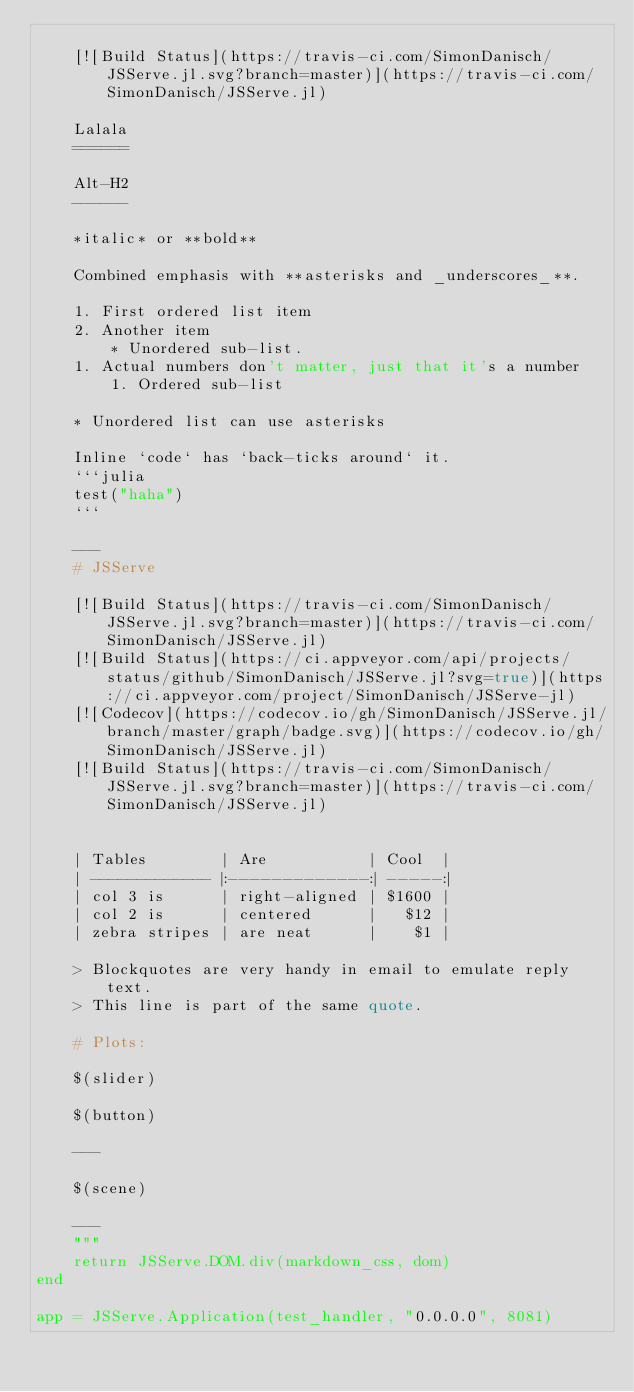<code> <loc_0><loc_0><loc_500><loc_500><_Julia_>
    [![Build Status](https://travis-ci.com/SimonDanisch/JSServe.jl.svg?branch=master)](https://travis-ci.com/SimonDanisch/JSServe.jl)

    Lalala
    ======

    Alt-H2
    ------

    *italic* or **bold**

    Combined emphasis with **asterisks and _underscores_**.

    1. First ordered list item
    2. Another item
        * Unordered sub-list.
    1. Actual numbers don't matter, just that it's a number
        1. Ordered sub-list

    * Unordered list can use asterisks

    Inline `code` has `back-ticks around` it.
    ```julia
    test("haha")
    ```

    ---
    # JSServe

    [![Build Status](https://travis-ci.com/SimonDanisch/JSServe.jl.svg?branch=master)](https://travis-ci.com/SimonDanisch/JSServe.jl)
    [![Build Status](https://ci.appveyor.com/api/projects/status/github/SimonDanisch/JSServe.jl?svg=true)](https://ci.appveyor.com/project/SimonDanisch/JSServe-jl)
    [![Codecov](https://codecov.io/gh/SimonDanisch/JSServe.jl/branch/master/graph/badge.svg)](https://codecov.io/gh/SimonDanisch/JSServe.jl)
    [![Build Status](https://travis-ci.com/SimonDanisch/JSServe.jl.svg?branch=master)](https://travis-ci.com/SimonDanisch/JSServe.jl)


    | Tables        | Are           | Cool  |
    | ------------- |:-------------:| -----:|
    | col 3 is      | right-aligned | $1600 |
    | col 2 is      | centered      |   $12 |
    | zebra stripes | are neat      |    $1 |

    > Blockquotes are very handy in email to emulate reply text.
    > This line is part of the same quote.

    # Plots:

    $(slider)

    $(button)

    ---

    $(scene)

    ---
    """
    return JSServe.DOM.div(markdown_css, dom)
end

app = JSServe.Application(test_handler, "0.0.0.0", 8081)
</code> 